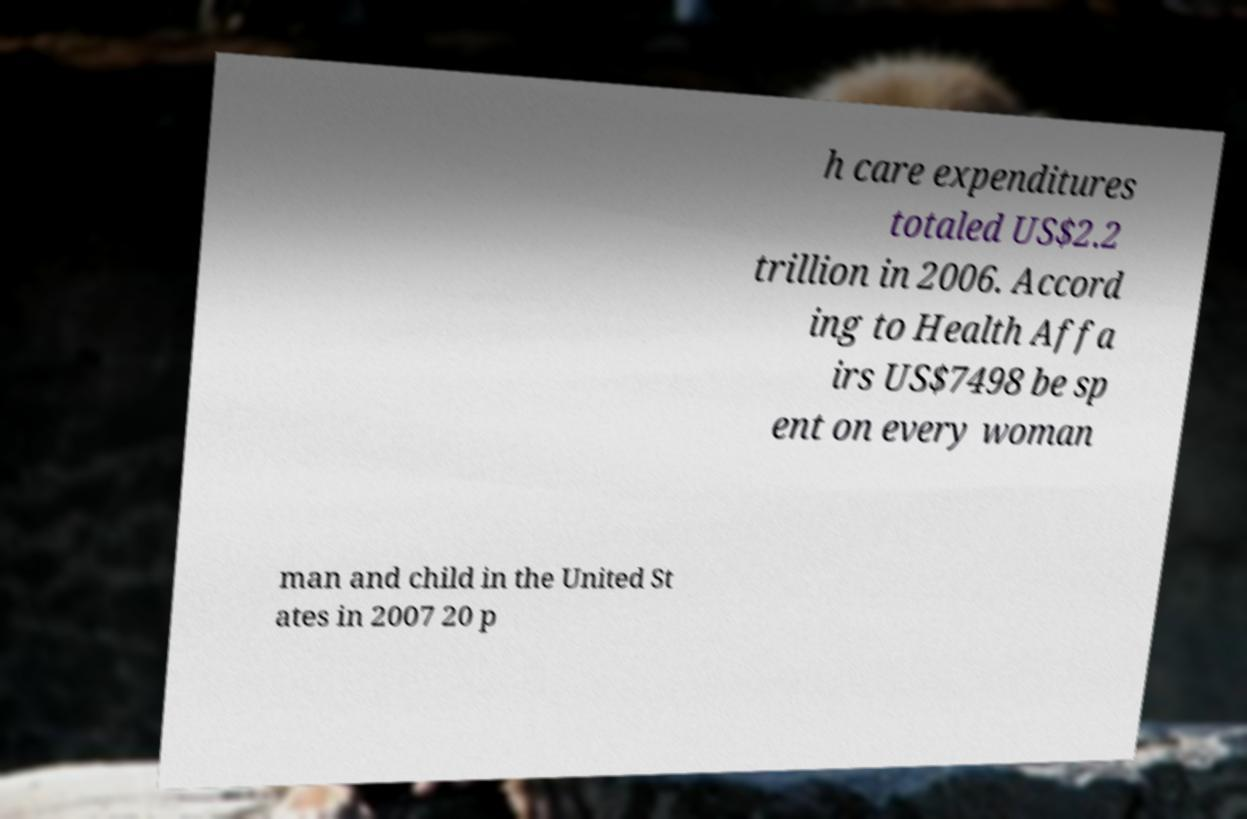Can you read and provide the text displayed in the image?This photo seems to have some interesting text. Can you extract and type it out for me? h care expenditures totaled US$2.2 trillion in 2006. Accord ing to Health Affa irs US$7498 be sp ent on every woman man and child in the United St ates in 2007 20 p 